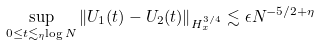<formula> <loc_0><loc_0><loc_500><loc_500>\sup _ { 0 \leq t \lesssim _ { \eta } \log N } \| U _ { 1 } ( t ) - U _ { 2 } ( t ) \| _ { H ^ { 3 / 4 } _ { x } } \lesssim \epsilon N ^ { - 5 / 2 + \eta }</formula> 